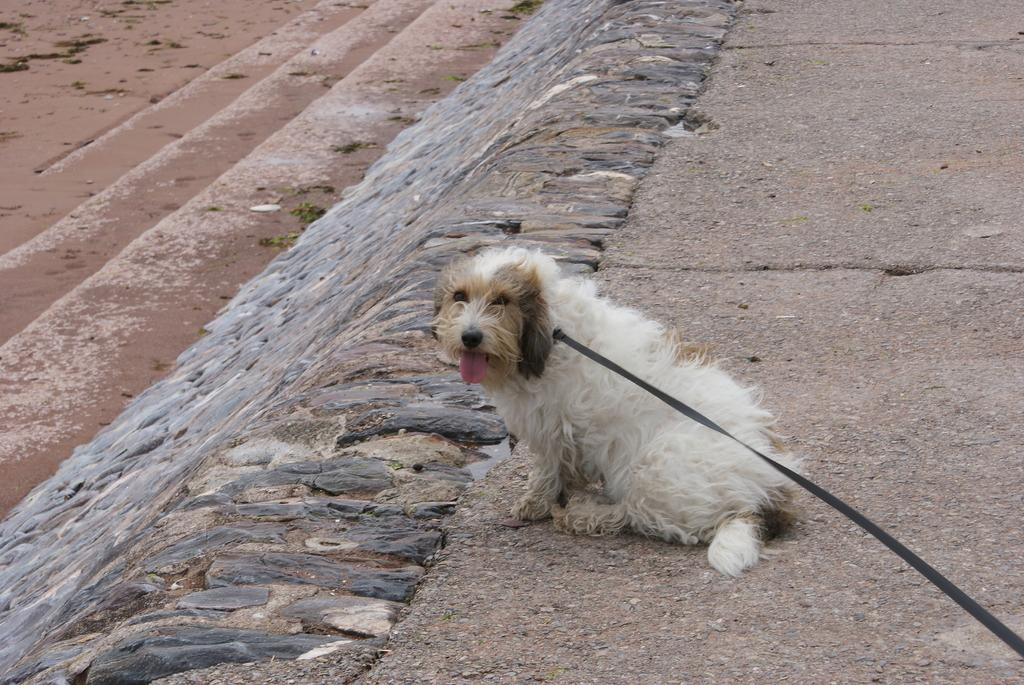What is the main subject in the center of the image? There is a dog in the center of the image. What can be seen at the bottom of the image? There is a road at the bottom of the image. How many geese are flying over the wilderness in the image? There are no geese or wilderness present in the image; it features a dog and a road. How many legs does the dog have in the image? The dog has four legs in the image. 